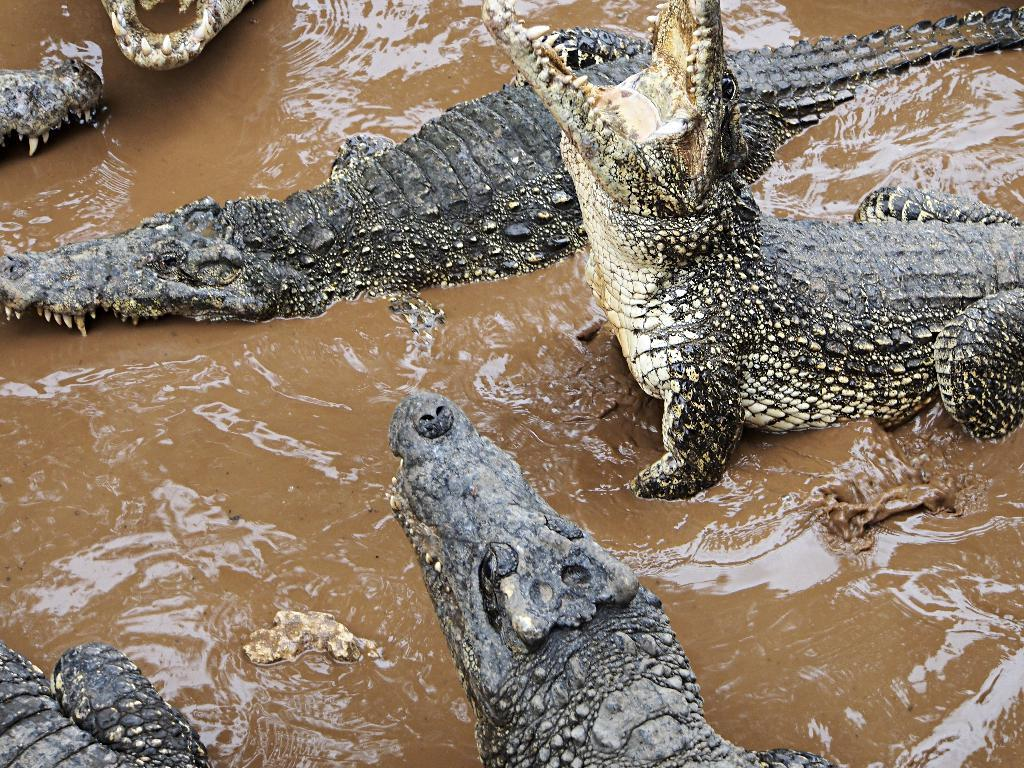What animals can be seen in the picture? There are crocodiles in the picture. What is visible at the bottom of the picture? There is water visible at the bottom of the picture. What type of profit can be seen in the picture? There is no mention of profit in the image, as it features crocodiles and water. 